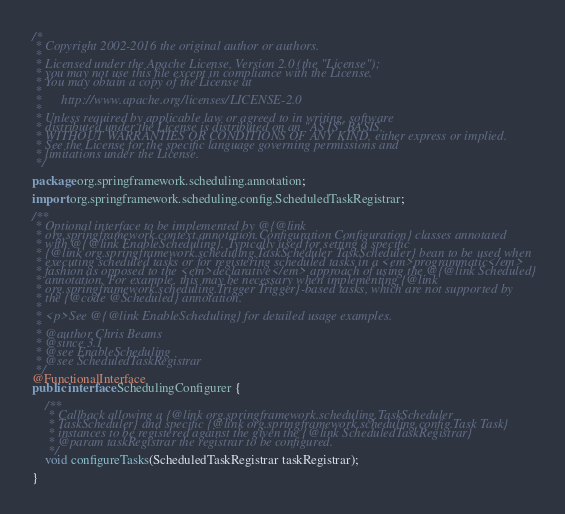Convert code to text. <code><loc_0><loc_0><loc_500><loc_500><_Java_>/*
 * Copyright 2002-2016 the original author or authors.
 *
 * Licensed under the Apache License, Version 2.0 (the "License");
 * you may not use this file except in compliance with the License.
 * You may obtain a copy of the License at
 *
 *      http://www.apache.org/licenses/LICENSE-2.0
 *
 * Unless required by applicable law or agreed to in writing, software
 * distributed under the License is distributed on an "AS IS" BASIS,
 * WITHOUT WARRANTIES OR CONDITIONS OF ANY KIND, either express or implied.
 * See the License for the specific language governing permissions and
 * limitations under the License.
 */

package org.springframework.scheduling.annotation;

import org.springframework.scheduling.config.ScheduledTaskRegistrar;

/**
 * Optional interface to be implemented by @{@link
 * org.springframework.context.annotation.Configuration Configuration} classes annotated
 * with @{@link EnableScheduling}. Typically used for setting a specific
 * {@link org.springframework.scheduling.TaskScheduler TaskScheduler} bean to be used when
 * executing scheduled tasks or for registering scheduled tasks in a <em>programmatic</em>
 * fashion as opposed to the <em>declarative</em> approach of using the @{@link Scheduled}
 * annotation. For example, this may be necessary when implementing {@link
 * org.springframework.scheduling.Trigger Trigger}-based tasks, which are not supported by
 * the {@code @Scheduled} annotation.
 *
 * <p>See @{@link EnableScheduling} for detailed usage examples.
 *
 * @author Chris Beams
 * @since 3.1
 * @see EnableScheduling
 * @see ScheduledTaskRegistrar
 */
@FunctionalInterface
public interface SchedulingConfigurer {

	/**
	 * Callback allowing a {@link org.springframework.scheduling.TaskScheduler
	 * TaskScheduler} and specific {@link org.springframework.scheduling.config.Task Task}
	 * instances to be registered against the given the {@link ScheduledTaskRegistrar}
	 * @param taskRegistrar the registrar to be configured.
	 */
	void configureTasks(ScheduledTaskRegistrar taskRegistrar);

}
</code> 